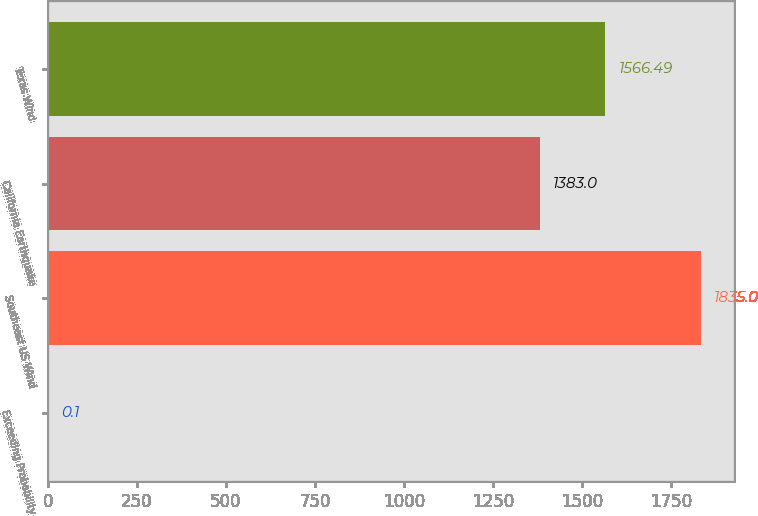Convert chart to OTSL. <chart><loc_0><loc_0><loc_500><loc_500><bar_chart><fcel>Exceeding Probability<fcel>Southeast US Wind<fcel>California Earthquake<fcel>Texas Wind<nl><fcel>0.1<fcel>1835<fcel>1383<fcel>1566.49<nl></chart> 